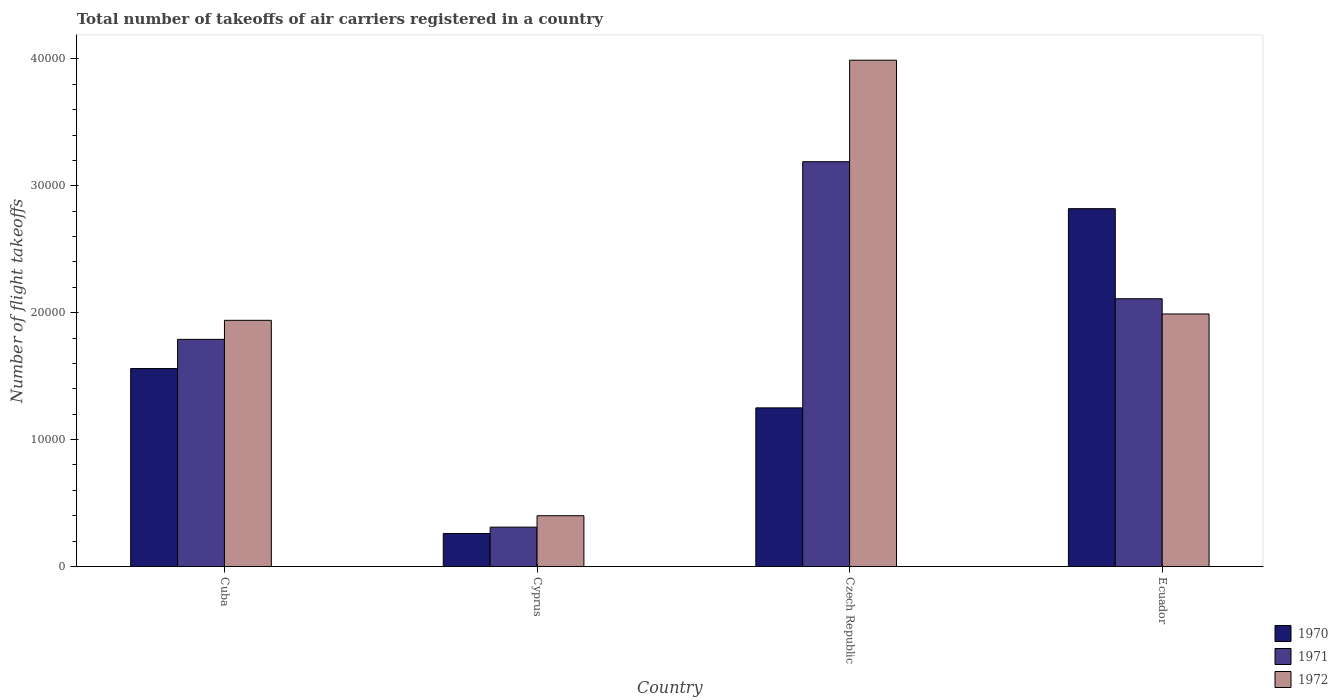How many different coloured bars are there?
Your response must be concise. 3. How many groups of bars are there?
Offer a terse response. 4. Are the number of bars on each tick of the X-axis equal?
Provide a short and direct response. Yes. How many bars are there on the 2nd tick from the left?
Provide a short and direct response. 3. What is the label of the 4th group of bars from the left?
Offer a terse response. Ecuador. What is the total number of flight takeoffs in 1970 in Cuba?
Offer a terse response. 1.56e+04. Across all countries, what is the maximum total number of flight takeoffs in 1972?
Keep it short and to the point. 3.99e+04. Across all countries, what is the minimum total number of flight takeoffs in 1971?
Your answer should be compact. 3100. In which country was the total number of flight takeoffs in 1970 maximum?
Your answer should be very brief. Ecuador. In which country was the total number of flight takeoffs in 1971 minimum?
Offer a terse response. Cyprus. What is the total total number of flight takeoffs in 1970 in the graph?
Provide a short and direct response. 5.89e+04. What is the difference between the total number of flight takeoffs in 1970 in Cuba and that in Cyprus?
Your answer should be compact. 1.30e+04. What is the difference between the total number of flight takeoffs in 1970 in Ecuador and the total number of flight takeoffs in 1971 in Cyprus?
Your answer should be very brief. 2.51e+04. What is the average total number of flight takeoffs in 1972 per country?
Ensure brevity in your answer.  2.08e+04. What is the difference between the total number of flight takeoffs of/in 1971 and total number of flight takeoffs of/in 1972 in Cuba?
Your response must be concise. -1500. In how many countries, is the total number of flight takeoffs in 1970 greater than 8000?
Offer a terse response. 3. What is the ratio of the total number of flight takeoffs in 1971 in Cuba to that in Ecuador?
Offer a terse response. 0.85. Is the difference between the total number of flight takeoffs in 1971 in Cuba and Ecuador greater than the difference between the total number of flight takeoffs in 1972 in Cuba and Ecuador?
Your answer should be very brief. No. What is the difference between the highest and the second highest total number of flight takeoffs in 1970?
Give a very brief answer. 1.26e+04. What is the difference between the highest and the lowest total number of flight takeoffs in 1971?
Give a very brief answer. 2.88e+04. Is the sum of the total number of flight takeoffs in 1972 in Cuba and Cyprus greater than the maximum total number of flight takeoffs in 1970 across all countries?
Offer a very short reply. No. What does the 2nd bar from the left in Czech Republic represents?
Ensure brevity in your answer.  1971. How many bars are there?
Offer a very short reply. 12. How many countries are there in the graph?
Keep it short and to the point. 4. Are the values on the major ticks of Y-axis written in scientific E-notation?
Keep it short and to the point. No. Where does the legend appear in the graph?
Your answer should be very brief. Bottom right. How are the legend labels stacked?
Offer a terse response. Vertical. What is the title of the graph?
Provide a short and direct response. Total number of takeoffs of air carriers registered in a country. What is the label or title of the X-axis?
Provide a succinct answer. Country. What is the label or title of the Y-axis?
Keep it short and to the point. Number of flight takeoffs. What is the Number of flight takeoffs of 1970 in Cuba?
Offer a very short reply. 1.56e+04. What is the Number of flight takeoffs of 1971 in Cuba?
Your response must be concise. 1.79e+04. What is the Number of flight takeoffs in 1972 in Cuba?
Your answer should be compact. 1.94e+04. What is the Number of flight takeoffs of 1970 in Cyprus?
Provide a succinct answer. 2600. What is the Number of flight takeoffs in 1971 in Cyprus?
Keep it short and to the point. 3100. What is the Number of flight takeoffs in 1972 in Cyprus?
Keep it short and to the point. 4000. What is the Number of flight takeoffs in 1970 in Czech Republic?
Keep it short and to the point. 1.25e+04. What is the Number of flight takeoffs of 1971 in Czech Republic?
Your response must be concise. 3.19e+04. What is the Number of flight takeoffs of 1972 in Czech Republic?
Give a very brief answer. 3.99e+04. What is the Number of flight takeoffs in 1970 in Ecuador?
Give a very brief answer. 2.82e+04. What is the Number of flight takeoffs in 1971 in Ecuador?
Make the answer very short. 2.11e+04. What is the Number of flight takeoffs in 1972 in Ecuador?
Make the answer very short. 1.99e+04. Across all countries, what is the maximum Number of flight takeoffs of 1970?
Your answer should be compact. 2.82e+04. Across all countries, what is the maximum Number of flight takeoffs of 1971?
Give a very brief answer. 3.19e+04. Across all countries, what is the maximum Number of flight takeoffs of 1972?
Offer a very short reply. 3.99e+04. Across all countries, what is the minimum Number of flight takeoffs of 1970?
Offer a very short reply. 2600. Across all countries, what is the minimum Number of flight takeoffs in 1971?
Provide a short and direct response. 3100. Across all countries, what is the minimum Number of flight takeoffs of 1972?
Your answer should be very brief. 4000. What is the total Number of flight takeoffs of 1970 in the graph?
Make the answer very short. 5.89e+04. What is the total Number of flight takeoffs of 1971 in the graph?
Give a very brief answer. 7.40e+04. What is the total Number of flight takeoffs of 1972 in the graph?
Your answer should be very brief. 8.32e+04. What is the difference between the Number of flight takeoffs in 1970 in Cuba and that in Cyprus?
Make the answer very short. 1.30e+04. What is the difference between the Number of flight takeoffs of 1971 in Cuba and that in Cyprus?
Provide a short and direct response. 1.48e+04. What is the difference between the Number of flight takeoffs in 1972 in Cuba and that in Cyprus?
Your answer should be compact. 1.54e+04. What is the difference between the Number of flight takeoffs of 1970 in Cuba and that in Czech Republic?
Your answer should be very brief. 3100. What is the difference between the Number of flight takeoffs of 1971 in Cuba and that in Czech Republic?
Give a very brief answer. -1.40e+04. What is the difference between the Number of flight takeoffs in 1972 in Cuba and that in Czech Republic?
Offer a very short reply. -2.05e+04. What is the difference between the Number of flight takeoffs in 1970 in Cuba and that in Ecuador?
Offer a terse response. -1.26e+04. What is the difference between the Number of flight takeoffs in 1971 in Cuba and that in Ecuador?
Provide a succinct answer. -3200. What is the difference between the Number of flight takeoffs of 1972 in Cuba and that in Ecuador?
Your answer should be compact. -500. What is the difference between the Number of flight takeoffs of 1970 in Cyprus and that in Czech Republic?
Offer a terse response. -9900. What is the difference between the Number of flight takeoffs of 1971 in Cyprus and that in Czech Republic?
Ensure brevity in your answer.  -2.88e+04. What is the difference between the Number of flight takeoffs of 1972 in Cyprus and that in Czech Republic?
Offer a terse response. -3.59e+04. What is the difference between the Number of flight takeoffs in 1970 in Cyprus and that in Ecuador?
Provide a succinct answer. -2.56e+04. What is the difference between the Number of flight takeoffs of 1971 in Cyprus and that in Ecuador?
Your response must be concise. -1.80e+04. What is the difference between the Number of flight takeoffs of 1972 in Cyprus and that in Ecuador?
Your answer should be very brief. -1.59e+04. What is the difference between the Number of flight takeoffs of 1970 in Czech Republic and that in Ecuador?
Ensure brevity in your answer.  -1.57e+04. What is the difference between the Number of flight takeoffs of 1971 in Czech Republic and that in Ecuador?
Provide a short and direct response. 1.08e+04. What is the difference between the Number of flight takeoffs in 1970 in Cuba and the Number of flight takeoffs in 1971 in Cyprus?
Offer a very short reply. 1.25e+04. What is the difference between the Number of flight takeoffs in 1970 in Cuba and the Number of flight takeoffs in 1972 in Cyprus?
Your answer should be very brief. 1.16e+04. What is the difference between the Number of flight takeoffs in 1971 in Cuba and the Number of flight takeoffs in 1972 in Cyprus?
Provide a short and direct response. 1.39e+04. What is the difference between the Number of flight takeoffs of 1970 in Cuba and the Number of flight takeoffs of 1971 in Czech Republic?
Provide a succinct answer. -1.63e+04. What is the difference between the Number of flight takeoffs of 1970 in Cuba and the Number of flight takeoffs of 1972 in Czech Republic?
Give a very brief answer. -2.43e+04. What is the difference between the Number of flight takeoffs in 1971 in Cuba and the Number of flight takeoffs in 1972 in Czech Republic?
Provide a succinct answer. -2.20e+04. What is the difference between the Number of flight takeoffs of 1970 in Cuba and the Number of flight takeoffs of 1971 in Ecuador?
Provide a succinct answer. -5500. What is the difference between the Number of flight takeoffs of 1970 in Cuba and the Number of flight takeoffs of 1972 in Ecuador?
Keep it short and to the point. -4300. What is the difference between the Number of flight takeoffs in 1971 in Cuba and the Number of flight takeoffs in 1972 in Ecuador?
Keep it short and to the point. -2000. What is the difference between the Number of flight takeoffs of 1970 in Cyprus and the Number of flight takeoffs of 1971 in Czech Republic?
Your answer should be compact. -2.93e+04. What is the difference between the Number of flight takeoffs in 1970 in Cyprus and the Number of flight takeoffs in 1972 in Czech Republic?
Provide a succinct answer. -3.73e+04. What is the difference between the Number of flight takeoffs of 1971 in Cyprus and the Number of flight takeoffs of 1972 in Czech Republic?
Offer a terse response. -3.68e+04. What is the difference between the Number of flight takeoffs in 1970 in Cyprus and the Number of flight takeoffs in 1971 in Ecuador?
Offer a very short reply. -1.85e+04. What is the difference between the Number of flight takeoffs in 1970 in Cyprus and the Number of flight takeoffs in 1972 in Ecuador?
Offer a terse response. -1.73e+04. What is the difference between the Number of flight takeoffs of 1971 in Cyprus and the Number of flight takeoffs of 1972 in Ecuador?
Provide a succinct answer. -1.68e+04. What is the difference between the Number of flight takeoffs in 1970 in Czech Republic and the Number of flight takeoffs in 1971 in Ecuador?
Make the answer very short. -8600. What is the difference between the Number of flight takeoffs of 1970 in Czech Republic and the Number of flight takeoffs of 1972 in Ecuador?
Your response must be concise. -7400. What is the difference between the Number of flight takeoffs of 1971 in Czech Republic and the Number of flight takeoffs of 1972 in Ecuador?
Provide a short and direct response. 1.20e+04. What is the average Number of flight takeoffs in 1970 per country?
Provide a short and direct response. 1.47e+04. What is the average Number of flight takeoffs of 1971 per country?
Make the answer very short. 1.85e+04. What is the average Number of flight takeoffs of 1972 per country?
Your answer should be compact. 2.08e+04. What is the difference between the Number of flight takeoffs in 1970 and Number of flight takeoffs in 1971 in Cuba?
Your response must be concise. -2300. What is the difference between the Number of flight takeoffs in 1970 and Number of flight takeoffs in 1972 in Cuba?
Your response must be concise. -3800. What is the difference between the Number of flight takeoffs of 1971 and Number of flight takeoffs of 1972 in Cuba?
Provide a succinct answer. -1500. What is the difference between the Number of flight takeoffs of 1970 and Number of flight takeoffs of 1971 in Cyprus?
Offer a very short reply. -500. What is the difference between the Number of flight takeoffs of 1970 and Number of flight takeoffs of 1972 in Cyprus?
Provide a short and direct response. -1400. What is the difference between the Number of flight takeoffs in 1971 and Number of flight takeoffs in 1972 in Cyprus?
Keep it short and to the point. -900. What is the difference between the Number of flight takeoffs of 1970 and Number of flight takeoffs of 1971 in Czech Republic?
Provide a succinct answer. -1.94e+04. What is the difference between the Number of flight takeoffs of 1970 and Number of flight takeoffs of 1972 in Czech Republic?
Offer a very short reply. -2.74e+04. What is the difference between the Number of flight takeoffs in 1971 and Number of flight takeoffs in 1972 in Czech Republic?
Offer a very short reply. -8000. What is the difference between the Number of flight takeoffs in 1970 and Number of flight takeoffs in 1971 in Ecuador?
Provide a succinct answer. 7100. What is the difference between the Number of flight takeoffs in 1970 and Number of flight takeoffs in 1972 in Ecuador?
Ensure brevity in your answer.  8300. What is the difference between the Number of flight takeoffs of 1971 and Number of flight takeoffs of 1972 in Ecuador?
Offer a very short reply. 1200. What is the ratio of the Number of flight takeoffs in 1971 in Cuba to that in Cyprus?
Offer a very short reply. 5.77. What is the ratio of the Number of flight takeoffs of 1972 in Cuba to that in Cyprus?
Make the answer very short. 4.85. What is the ratio of the Number of flight takeoffs of 1970 in Cuba to that in Czech Republic?
Your answer should be compact. 1.25. What is the ratio of the Number of flight takeoffs of 1971 in Cuba to that in Czech Republic?
Provide a short and direct response. 0.56. What is the ratio of the Number of flight takeoffs in 1972 in Cuba to that in Czech Republic?
Offer a terse response. 0.49. What is the ratio of the Number of flight takeoffs in 1970 in Cuba to that in Ecuador?
Provide a succinct answer. 0.55. What is the ratio of the Number of flight takeoffs of 1971 in Cuba to that in Ecuador?
Keep it short and to the point. 0.85. What is the ratio of the Number of flight takeoffs in 1972 in Cuba to that in Ecuador?
Provide a short and direct response. 0.97. What is the ratio of the Number of flight takeoffs of 1970 in Cyprus to that in Czech Republic?
Ensure brevity in your answer.  0.21. What is the ratio of the Number of flight takeoffs of 1971 in Cyprus to that in Czech Republic?
Your answer should be compact. 0.1. What is the ratio of the Number of flight takeoffs of 1972 in Cyprus to that in Czech Republic?
Provide a succinct answer. 0.1. What is the ratio of the Number of flight takeoffs in 1970 in Cyprus to that in Ecuador?
Make the answer very short. 0.09. What is the ratio of the Number of flight takeoffs of 1971 in Cyprus to that in Ecuador?
Your response must be concise. 0.15. What is the ratio of the Number of flight takeoffs in 1972 in Cyprus to that in Ecuador?
Provide a short and direct response. 0.2. What is the ratio of the Number of flight takeoffs in 1970 in Czech Republic to that in Ecuador?
Give a very brief answer. 0.44. What is the ratio of the Number of flight takeoffs in 1971 in Czech Republic to that in Ecuador?
Your answer should be compact. 1.51. What is the ratio of the Number of flight takeoffs in 1972 in Czech Republic to that in Ecuador?
Your answer should be very brief. 2. What is the difference between the highest and the second highest Number of flight takeoffs of 1970?
Keep it short and to the point. 1.26e+04. What is the difference between the highest and the second highest Number of flight takeoffs of 1971?
Give a very brief answer. 1.08e+04. What is the difference between the highest and the lowest Number of flight takeoffs in 1970?
Give a very brief answer. 2.56e+04. What is the difference between the highest and the lowest Number of flight takeoffs in 1971?
Offer a terse response. 2.88e+04. What is the difference between the highest and the lowest Number of flight takeoffs of 1972?
Your answer should be very brief. 3.59e+04. 